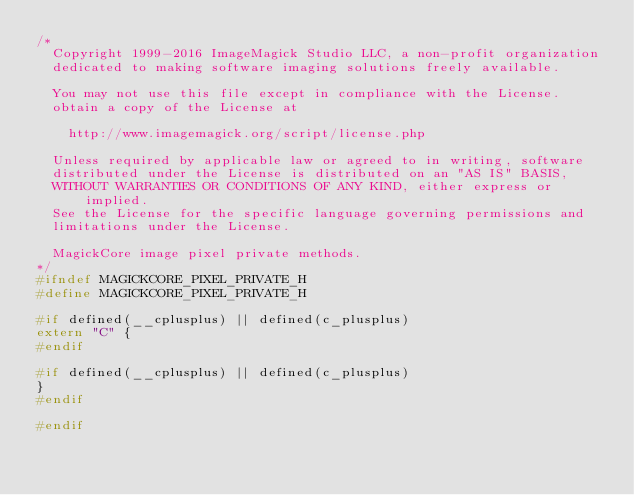<code> <loc_0><loc_0><loc_500><loc_500><_C_>/*
  Copyright 1999-2016 ImageMagick Studio LLC, a non-profit organization
  dedicated to making software imaging solutions freely available.

  You may not use this file except in compliance with the License.
  obtain a copy of the License at

    http://www.imagemagick.org/script/license.php

  Unless required by applicable law or agreed to in writing, software
  distributed under the License is distributed on an "AS IS" BASIS,
  WITHOUT WARRANTIES OR CONDITIONS OF ANY KIND, either express or implied.
  See the License for the specific language governing permissions and
  limitations under the License.

  MagickCore image pixel private methods.
*/
#ifndef MAGICKCORE_PIXEL_PRIVATE_H
#define MAGICKCORE_PIXEL_PRIVATE_H

#if defined(__cplusplus) || defined(c_plusplus)
extern "C" {
#endif

#if defined(__cplusplus) || defined(c_plusplus)
}
#endif

#endif
</code> 